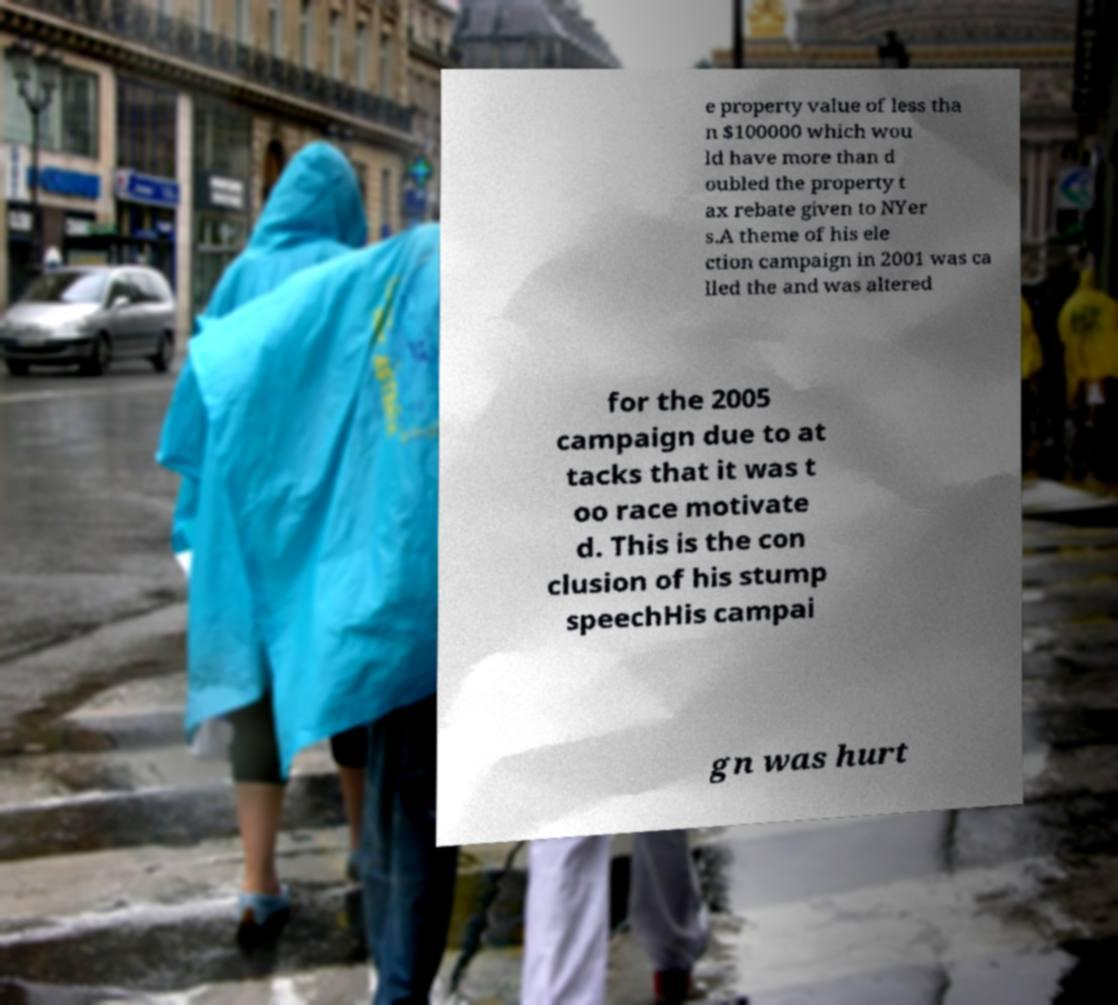Could you assist in decoding the text presented in this image and type it out clearly? e property value of less tha n $100000 which wou ld have more than d oubled the property t ax rebate given to NYer s.A theme of his ele ction campaign in 2001 was ca lled the and was altered for the 2005 campaign due to at tacks that it was t oo race motivate d. This is the con clusion of his stump speechHis campai gn was hurt 